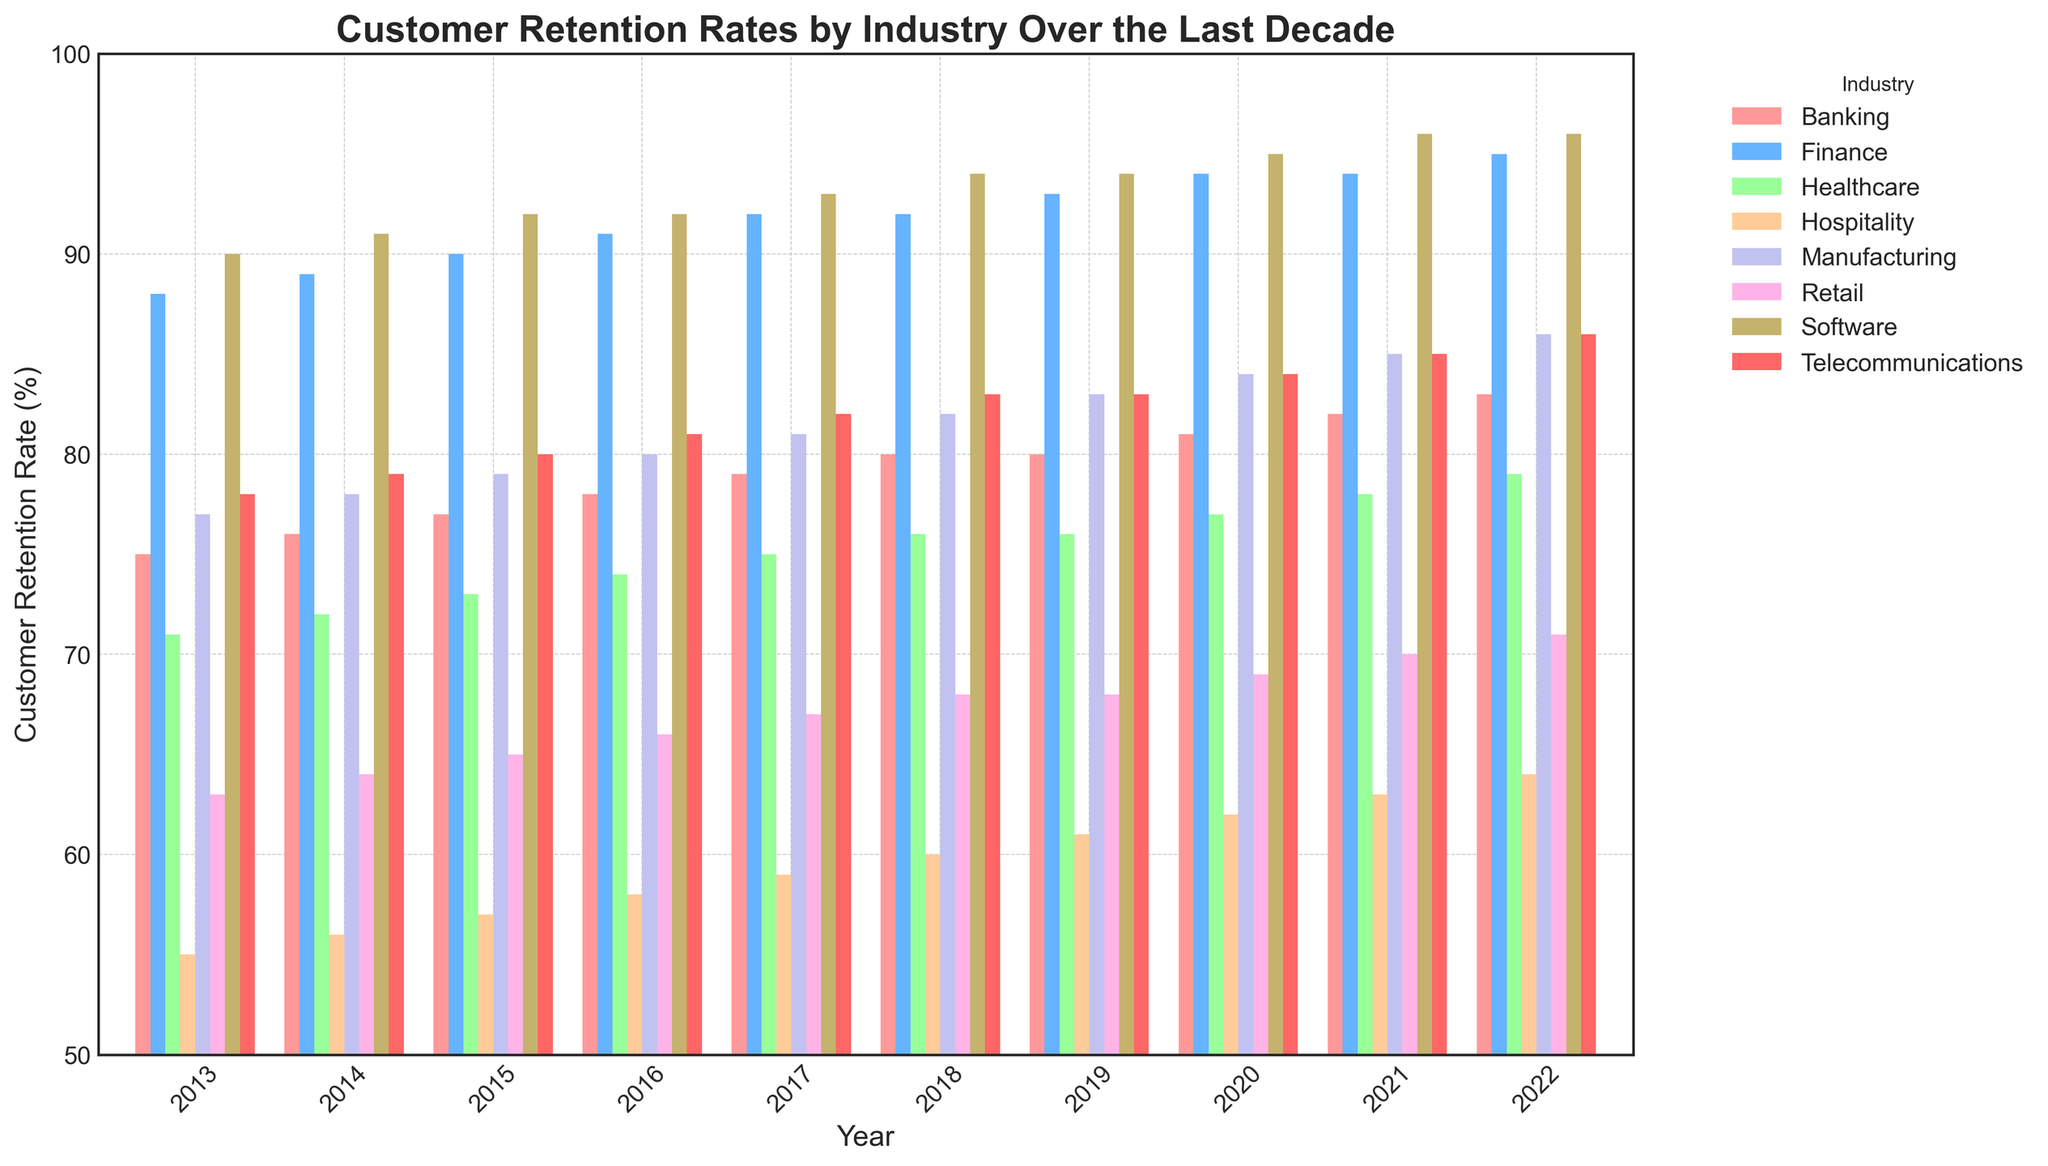What industry has the highest customer retention rate in 2022? To find the highest customer retention rate in 2022, look for the tallest bar in the year 2022. The Software industry has the highest bar, indicating the highest retention rate.
Answer: Software Which industry witnessed the steepest growth in customer retention rates from 2013 to 2022? Calculate the increase for each industry from 2013 to 2022, and compare them. Software increased from 90% to 96%, and Telecommunications increased from 78% to 86%. By comparing all, Software had the maximum growth.
Answer: Software How did the customer retention rates in Telecommunications change over the last decade? Observe the height of the bars for Telecommunications from 2013 to 2022. The rates increased each year from 78% in 2013 to 86% in 2022.
Answer: Increased from 78% to 86% Between 2013 and 2022, which industry had the smallest increase in customer retention rates? Calculate the increase for each industry over the years. For Retail, it's 8% (71-63). Compare increases across all industries. Hospitality increased by 9% (64-55), which is the smallest among all.
Answer: Hospitality In 2018, which industry had the highest customer retention rate? Look at the bars for the year 2018 and determine the tallest one. The Software industry has the tallest bar in 2018.
Answer: Software Which industry had the highest customer retention growth between 2016 and 2020? Compare the increase from 2016 to 2020 for each industry. Software increased by 3% (95-92). Healthcare increased by 3% (77-74), etc. Software, Telecommunications, Healthcare, Manufacturing, Finance, and others show growth, but evaluation shows Software's 3% as highest compared to other minimal increases.
Answer: Software How did the customer retention rate for Banking change from 2018 to 2019 and from 2019 to 2020? Observe and compare the bars' heights for Banking in these years. From 2018 to 2019, it stayed at 80%. From 2019 to 2020, it increased by 1% to 81%.
Answer: 80% to 80%, then 80% to 81% Which industry consistently improved its customer retention rate each year from 2013 to 2022 without any year-to-year decline? Identify the industries with continuously rising bars each year without decline. Reviewing each, Software shows consistent increases every year from 90% to 96%.
Answer: Software What is the average customer retention rate of the Retail industry over the past decade? Sum the retention rates of Retail from 2013 to 2022, then divide by 10. The sums are (63+64+65+66+67+68+68+69+70+71) = 671, so the average is 671/10 = 67.1
Answer: 67.1% Comparing 2020 and 2021, which industry saw the largest percentage increase in customer retention rate? Calculate the percentage increase for each industry by comparing 2020 and 2021. e.g., Finance from 94 to 94 is 0%, Software from 95 to 96 is ≈ 1.05%. Healthcare from 77 to 78 is ≈ 1.30%. Healthcare had the largest percentage increase.
Answer: Healthcare 